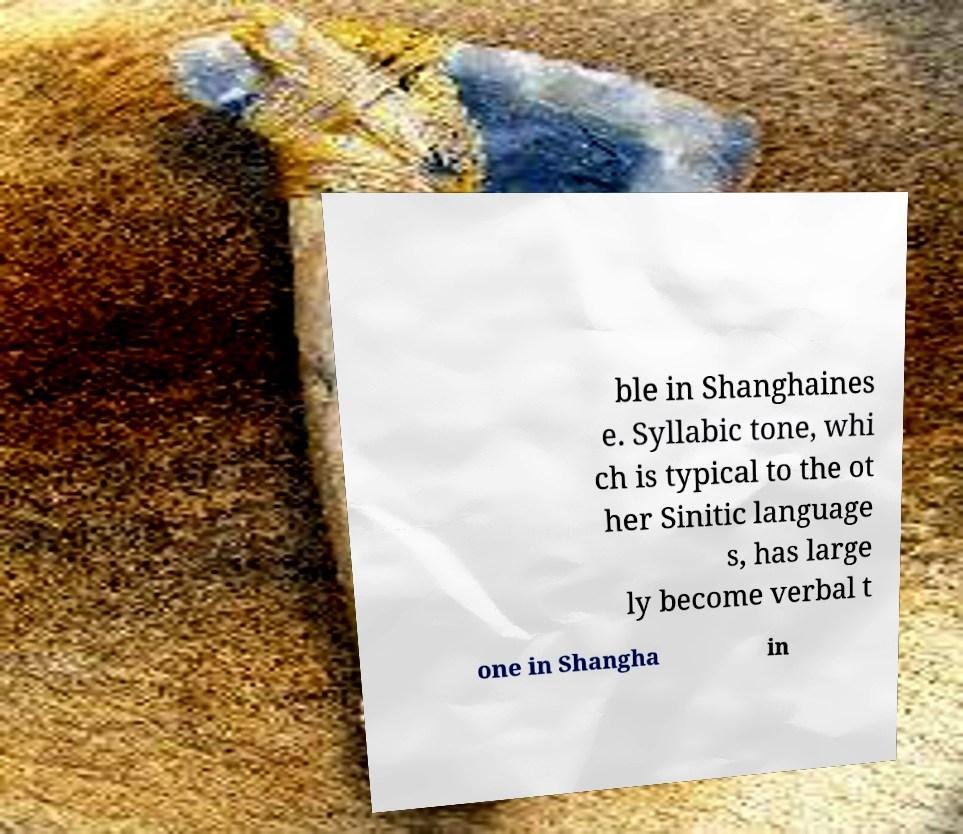There's text embedded in this image that I need extracted. Can you transcribe it verbatim? ble in Shanghaines e. Syllabic tone, whi ch is typical to the ot her Sinitic language s, has large ly become verbal t one in Shangha in 